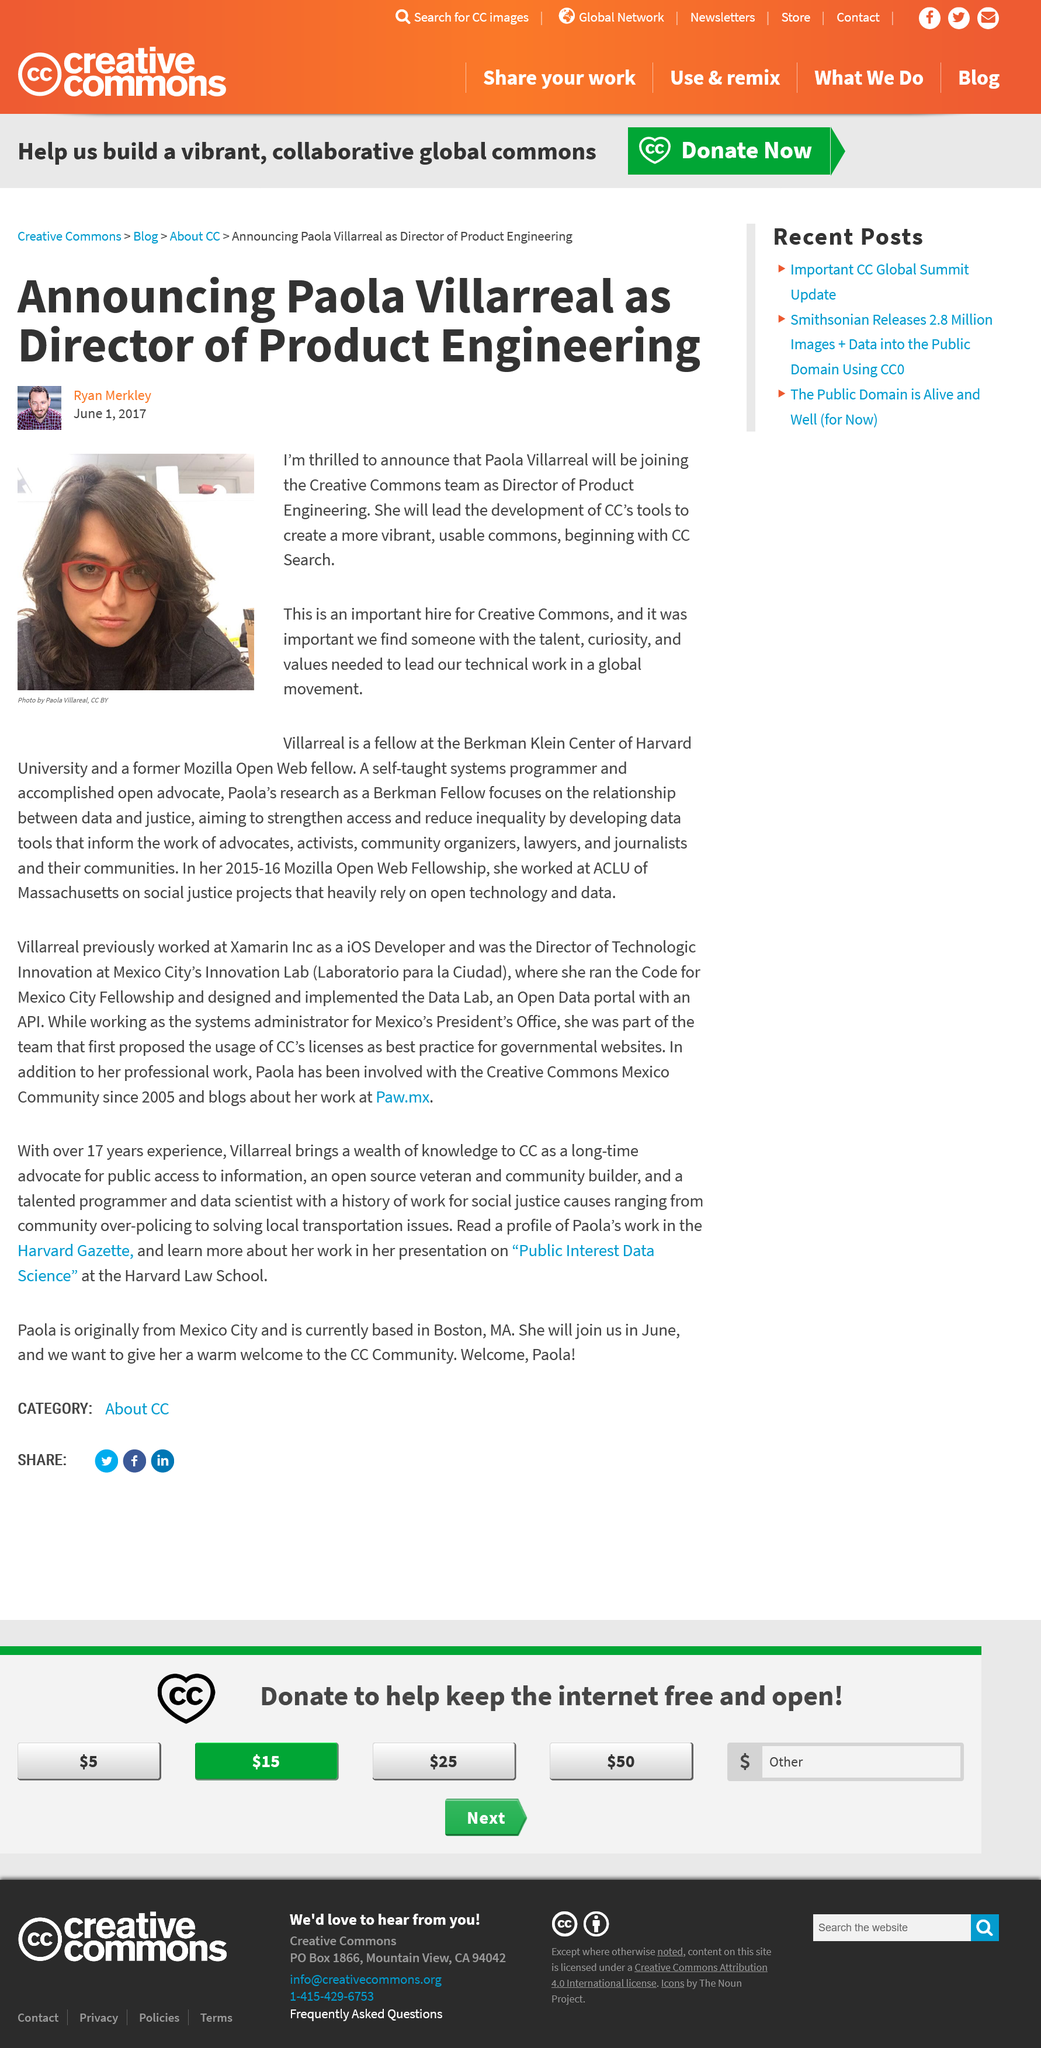Mention a couple of crucial points in this snapshot. The author of this article is Ryan Merkley. Paola Villarreal is the Director of Product Engineering. 